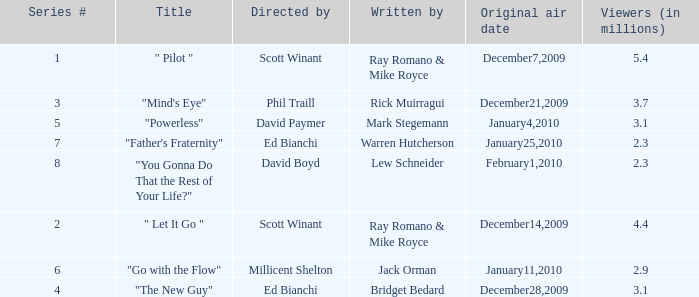How many episodes are written by Lew Schneider? 1.0. 